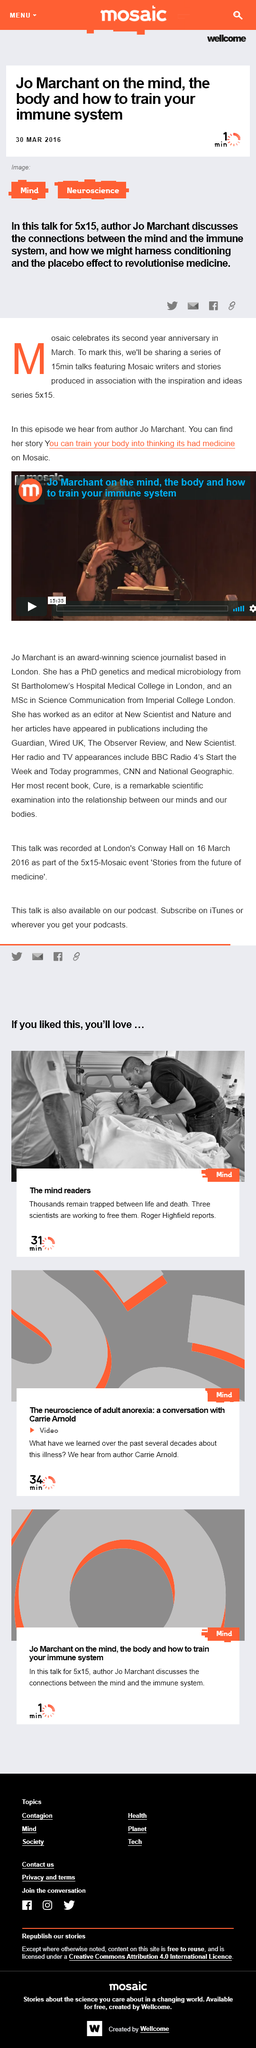Give some essential details in this illustration. On March 30, 2016, this article was written. This article pertains to the fields of Mind and Neuroscience. Mosaic celebrates its anniversary in March. 